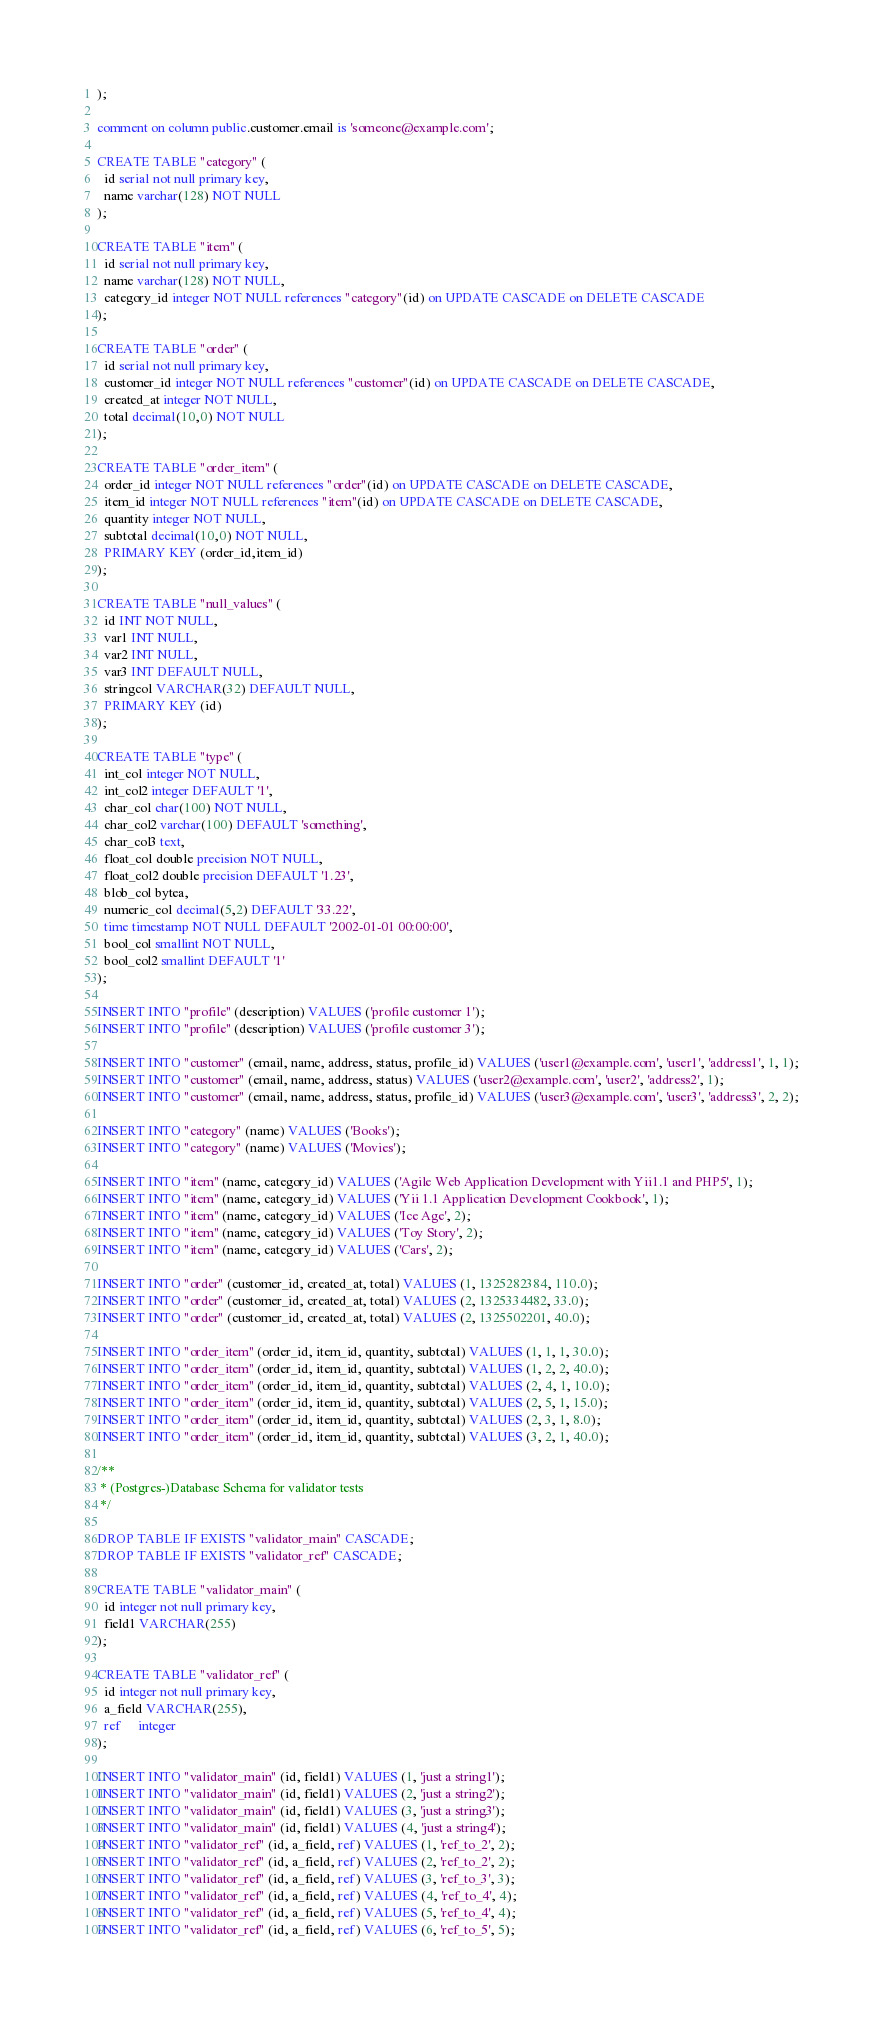Convert code to text. <code><loc_0><loc_0><loc_500><loc_500><_SQL_>);

comment on column public.customer.email is 'someone@example.com';

CREATE TABLE "category" (
  id serial not null primary key,
  name varchar(128) NOT NULL
);

CREATE TABLE "item" (
  id serial not null primary key,
  name varchar(128) NOT NULL,
  category_id integer NOT NULL references "category"(id) on UPDATE CASCADE on DELETE CASCADE
);

CREATE TABLE "order" (
  id serial not null primary key,
  customer_id integer NOT NULL references "customer"(id) on UPDATE CASCADE on DELETE CASCADE,
  created_at integer NOT NULL,
  total decimal(10,0) NOT NULL
);

CREATE TABLE "order_item" (
  order_id integer NOT NULL references "order"(id) on UPDATE CASCADE on DELETE CASCADE,
  item_id integer NOT NULL references "item"(id) on UPDATE CASCADE on DELETE CASCADE,
  quantity integer NOT NULL,
  subtotal decimal(10,0) NOT NULL,
  PRIMARY KEY (order_id,item_id)
);

CREATE TABLE "null_values" (
  id INT NOT NULL,
  var1 INT NULL,
  var2 INT NULL,
  var3 INT DEFAULT NULL,
  stringcol VARCHAR(32) DEFAULT NULL,
  PRIMARY KEY (id)
);

CREATE TABLE "type" (
  int_col integer NOT NULL,
  int_col2 integer DEFAULT '1',
  char_col char(100) NOT NULL,
  char_col2 varchar(100) DEFAULT 'something',
  char_col3 text,
  float_col double precision NOT NULL,
  float_col2 double precision DEFAULT '1.23',
  blob_col bytea,
  numeric_col decimal(5,2) DEFAULT '33.22',
  time timestamp NOT NULL DEFAULT '2002-01-01 00:00:00',
  bool_col smallint NOT NULL,
  bool_col2 smallint DEFAULT '1'
);

INSERT INTO "profile" (description) VALUES ('profile customer 1');
INSERT INTO "profile" (description) VALUES ('profile customer 3');

INSERT INTO "customer" (email, name, address, status, profile_id) VALUES ('user1@example.com', 'user1', 'address1', 1, 1);
INSERT INTO "customer" (email, name, address, status) VALUES ('user2@example.com', 'user2', 'address2', 1);
INSERT INTO "customer" (email, name, address, status, profile_id) VALUES ('user3@example.com', 'user3', 'address3', 2, 2);

INSERT INTO "category" (name) VALUES ('Books');
INSERT INTO "category" (name) VALUES ('Movies');

INSERT INTO "item" (name, category_id) VALUES ('Agile Web Application Development with Yii1.1 and PHP5', 1);
INSERT INTO "item" (name, category_id) VALUES ('Yii 1.1 Application Development Cookbook', 1);
INSERT INTO "item" (name, category_id) VALUES ('Ice Age', 2);
INSERT INTO "item" (name, category_id) VALUES ('Toy Story', 2);
INSERT INTO "item" (name, category_id) VALUES ('Cars', 2);

INSERT INTO "order" (customer_id, created_at, total) VALUES (1, 1325282384, 110.0);
INSERT INTO "order" (customer_id, created_at, total) VALUES (2, 1325334482, 33.0);
INSERT INTO "order" (customer_id, created_at, total) VALUES (2, 1325502201, 40.0);

INSERT INTO "order_item" (order_id, item_id, quantity, subtotal) VALUES (1, 1, 1, 30.0);
INSERT INTO "order_item" (order_id, item_id, quantity, subtotal) VALUES (1, 2, 2, 40.0);
INSERT INTO "order_item" (order_id, item_id, quantity, subtotal) VALUES (2, 4, 1, 10.0);
INSERT INTO "order_item" (order_id, item_id, quantity, subtotal) VALUES (2, 5, 1, 15.0);
INSERT INTO "order_item" (order_id, item_id, quantity, subtotal) VALUES (2, 3, 1, 8.0);
INSERT INTO "order_item" (order_id, item_id, quantity, subtotal) VALUES (3, 2, 1, 40.0);

/**
 * (Postgres-)Database Schema for validator tests
 */

DROP TABLE IF EXISTS "validator_main" CASCADE;
DROP TABLE IF EXISTS "validator_ref" CASCADE;

CREATE TABLE "validator_main" (
  id integer not null primary key,
  field1 VARCHAR(255)
);

CREATE TABLE "validator_ref" (
  id integer not null primary key,
  a_field VARCHAR(255),
  ref     integer
);

INSERT INTO "validator_main" (id, field1) VALUES (1, 'just a string1');
INSERT INTO "validator_main" (id, field1) VALUES (2, 'just a string2');
INSERT INTO "validator_main" (id, field1) VALUES (3, 'just a string3');
INSERT INTO "validator_main" (id, field1) VALUES (4, 'just a string4');
INSERT INTO "validator_ref" (id, a_field, ref) VALUES (1, 'ref_to_2', 2);
INSERT INTO "validator_ref" (id, a_field, ref) VALUES (2, 'ref_to_2', 2);
INSERT INTO "validator_ref" (id, a_field, ref) VALUES (3, 'ref_to_3', 3);
INSERT INTO "validator_ref" (id, a_field, ref) VALUES (4, 'ref_to_4', 4);
INSERT INTO "validator_ref" (id, a_field, ref) VALUES (5, 'ref_to_4', 4);
INSERT INTO "validator_ref" (id, a_field, ref) VALUES (6, 'ref_to_5', 5);
</code> 